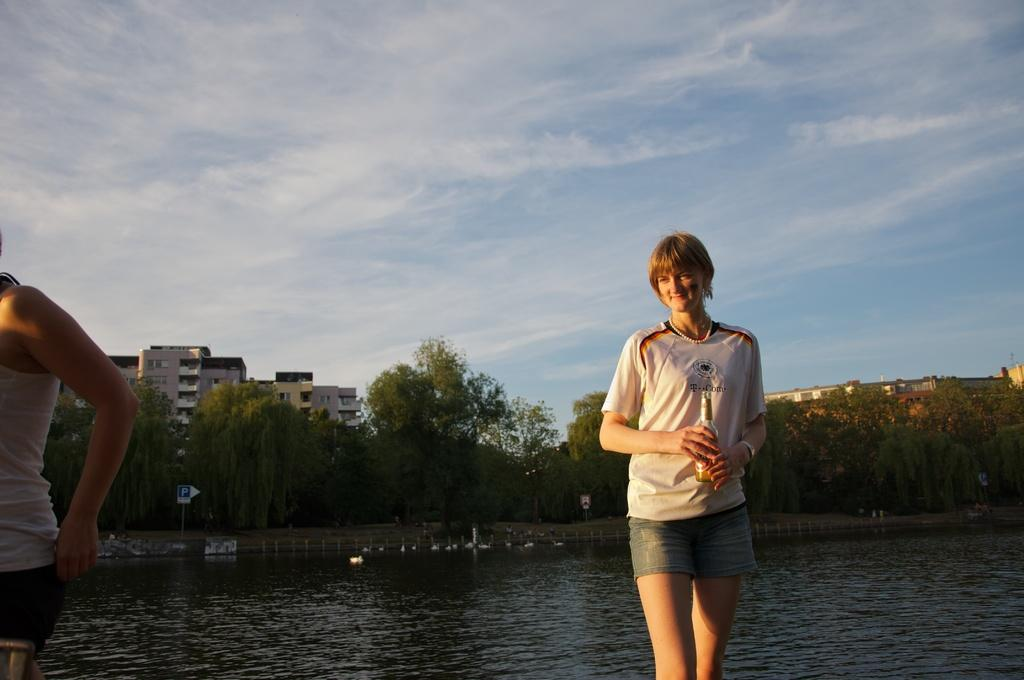Who is present in the image? There is a woman in the image. What is the woman holding in the image? The woman is holding a beer bottle. What is the woman wearing in the image? The woman is wearing a white t-shirt. What natural feature can be seen in the image? There is a river visible in the image. What type of vegetation is visible in the background of the image? There are trees in the background of the image. What type of man-made structures are visible in the background of the image? There are houses in the background of the image. What type of bear can be seen interacting with the woman in the image? There is no bear present in the image; the woman is holding a beer bottle. What is the plot of the story being told in the image? The image is not a story, so there is no plot to describe. 